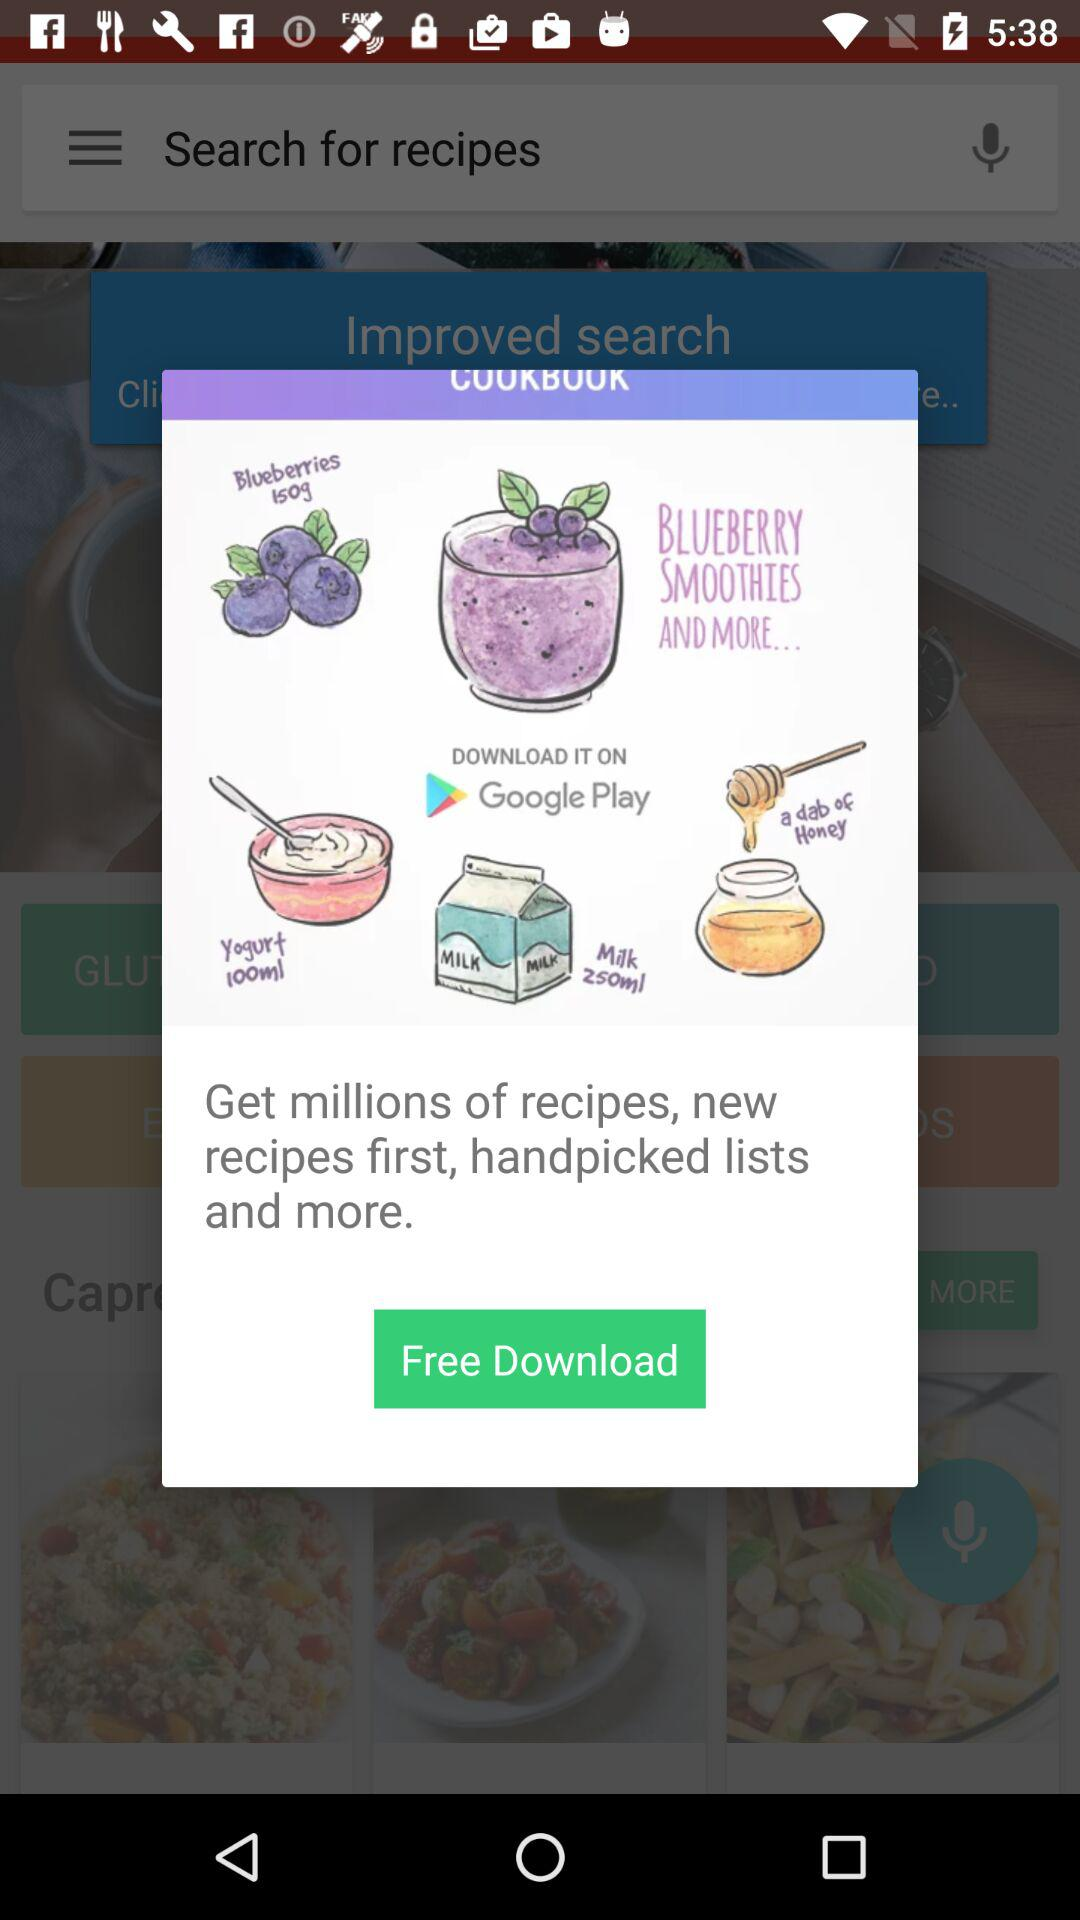What is the recipe book name?
When the provided information is insufficient, respond with <no answer>. <no answer> 